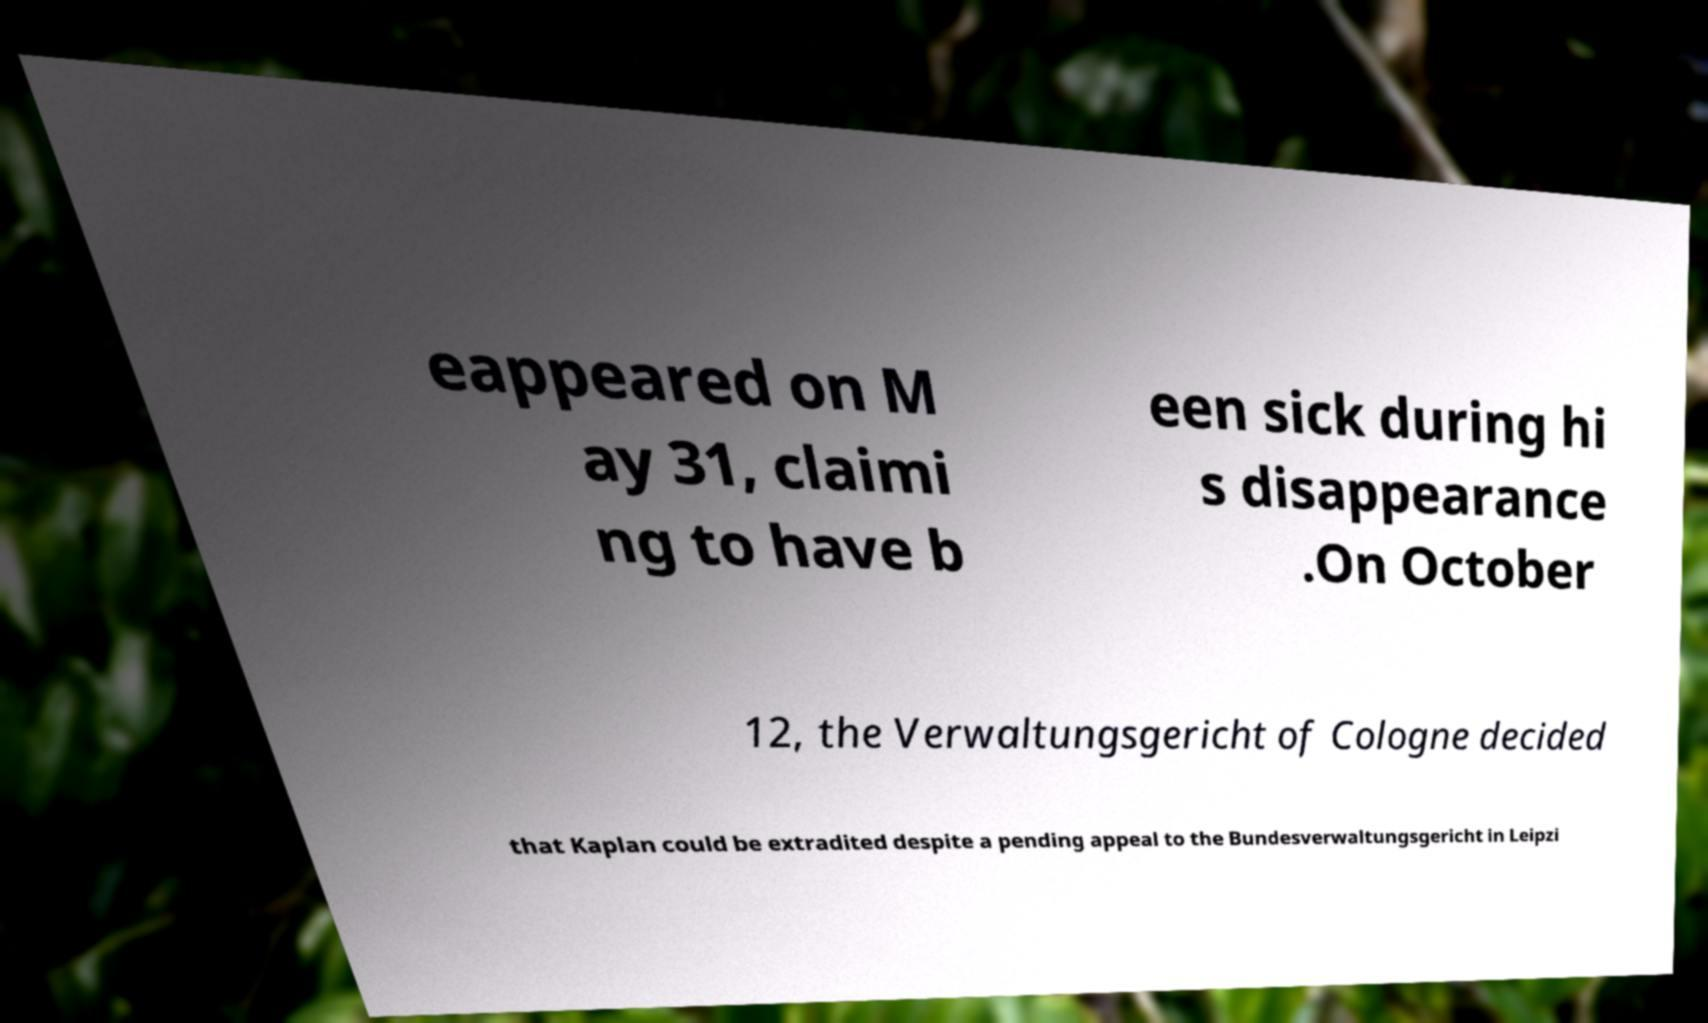There's text embedded in this image that I need extracted. Can you transcribe it verbatim? eappeared on M ay 31, claimi ng to have b een sick during hi s disappearance .On October 12, the Verwaltungsgericht of Cologne decided that Kaplan could be extradited despite a pending appeal to the Bundesverwaltungsgericht in Leipzi 